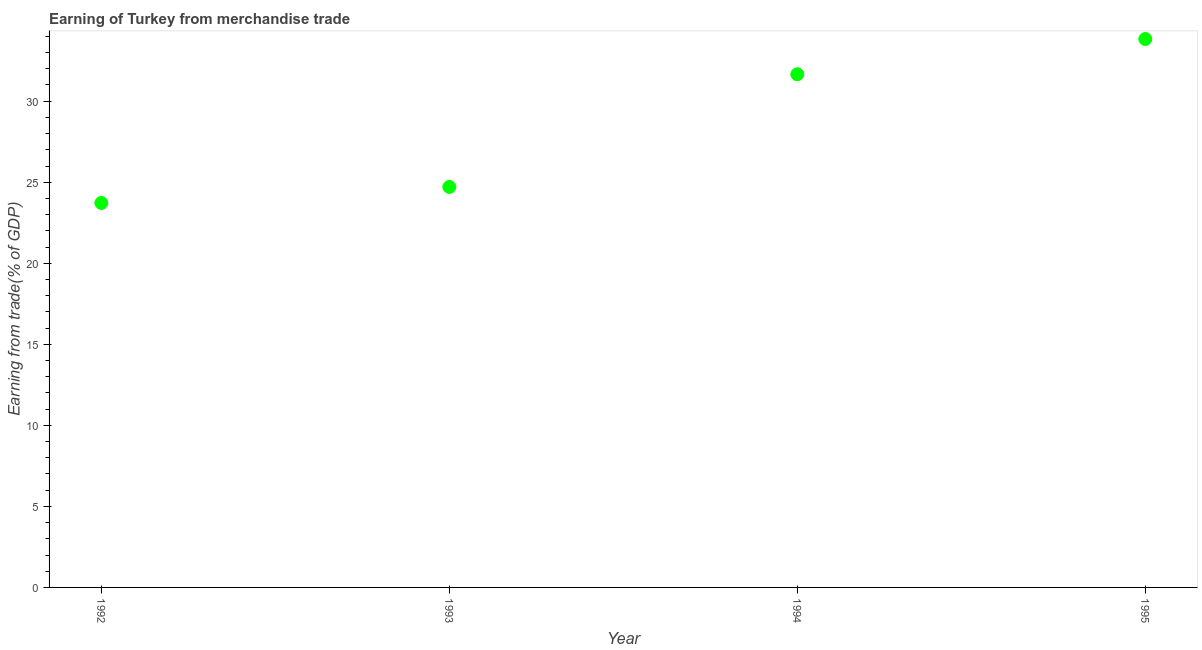What is the earning from merchandise trade in 1992?
Offer a terse response. 23.72. Across all years, what is the maximum earning from merchandise trade?
Make the answer very short. 33.84. Across all years, what is the minimum earning from merchandise trade?
Your answer should be compact. 23.72. In which year was the earning from merchandise trade maximum?
Provide a succinct answer. 1995. What is the sum of the earning from merchandise trade?
Offer a very short reply. 113.92. What is the difference between the earning from merchandise trade in 1992 and 1993?
Your answer should be compact. -0.99. What is the average earning from merchandise trade per year?
Your response must be concise. 28.48. What is the median earning from merchandise trade?
Make the answer very short. 28.18. What is the ratio of the earning from merchandise trade in 1992 to that in 1993?
Provide a succinct answer. 0.96. Is the earning from merchandise trade in 1992 less than that in 1995?
Your answer should be very brief. Yes. What is the difference between the highest and the second highest earning from merchandise trade?
Offer a terse response. 2.18. Is the sum of the earning from merchandise trade in 1992 and 1994 greater than the maximum earning from merchandise trade across all years?
Offer a very short reply. Yes. What is the difference between the highest and the lowest earning from merchandise trade?
Ensure brevity in your answer.  10.11. In how many years, is the earning from merchandise trade greater than the average earning from merchandise trade taken over all years?
Provide a short and direct response. 2. How many dotlines are there?
Ensure brevity in your answer.  1. How many years are there in the graph?
Ensure brevity in your answer.  4. What is the difference between two consecutive major ticks on the Y-axis?
Give a very brief answer. 5. Are the values on the major ticks of Y-axis written in scientific E-notation?
Offer a terse response. No. Does the graph contain grids?
Keep it short and to the point. No. What is the title of the graph?
Provide a succinct answer. Earning of Turkey from merchandise trade. What is the label or title of the X-axis?
Offer a very short reply. Year. What is the label or title of the Y-axis?
Make the answer very short. Earning from trade(% of GDP). What is the Earning from trade(% of GDP) in 1992?
Offer a terse response. 23.72. What is the Earning from trade(% of GDP) in 1993?
Provide a succinct answer. 24.71. What is the Earning from trade(% of GDP) in 1994?
Make the answer very short. 31.66. What is the Earning from trade(% of GDP) in 1995?
Make the answer very short. 33.84. What is the difference between the Earning from trade(% of GDP) in 1992 and 1993?
Keep it short and to the point. -0.99. What is the difference between the Earning from trade(% of GDP) in 1992 and 1994?
Make the answer very short. -7.94. What is the difference between the Earning from trade(% of GDP) in 1992 and 1995?
Provide a short and direct response. -10.11. What is the difference between the Earning from trade(% of GDP) in 1993 and 1994?
Provide a short and direct response. -6.95. What is the difference between the Earning from trade(% of GDP) in 1993 and 1995?
Your response must be concise. -9.13. What is the difference between the Earning from trade(% of GDP) in 1994 and 1995?
Your answer should be very brief. -2.18. What is the ratio of the Earning from trade(% of GDP) in 1992 to that in 1993?
Your response must be concise. 0.96. What is the ratio of the Earning from trade(% of GDP) in 1992 to that in 1994?
Keep it short and to the point. 0.75. What is the ratio of the Earning from trade(% of GDP) in 1992 to that in 1995?
Ensure brevity in your answer.  0.7. What is the ratio of the Earning from trade(% of GDP) in 1993 to that in 1994?
Ensure brevity in your answer.  0.78. What is the ratio of the Earning from trade(% of GDP) in 1993 to that in 1995?
Give a very brief answer. 0.73. What is the ratio of the Earning from trade(% of GDP) in 1994 to that in 1995?
Give a very brief answer. 0.94. 